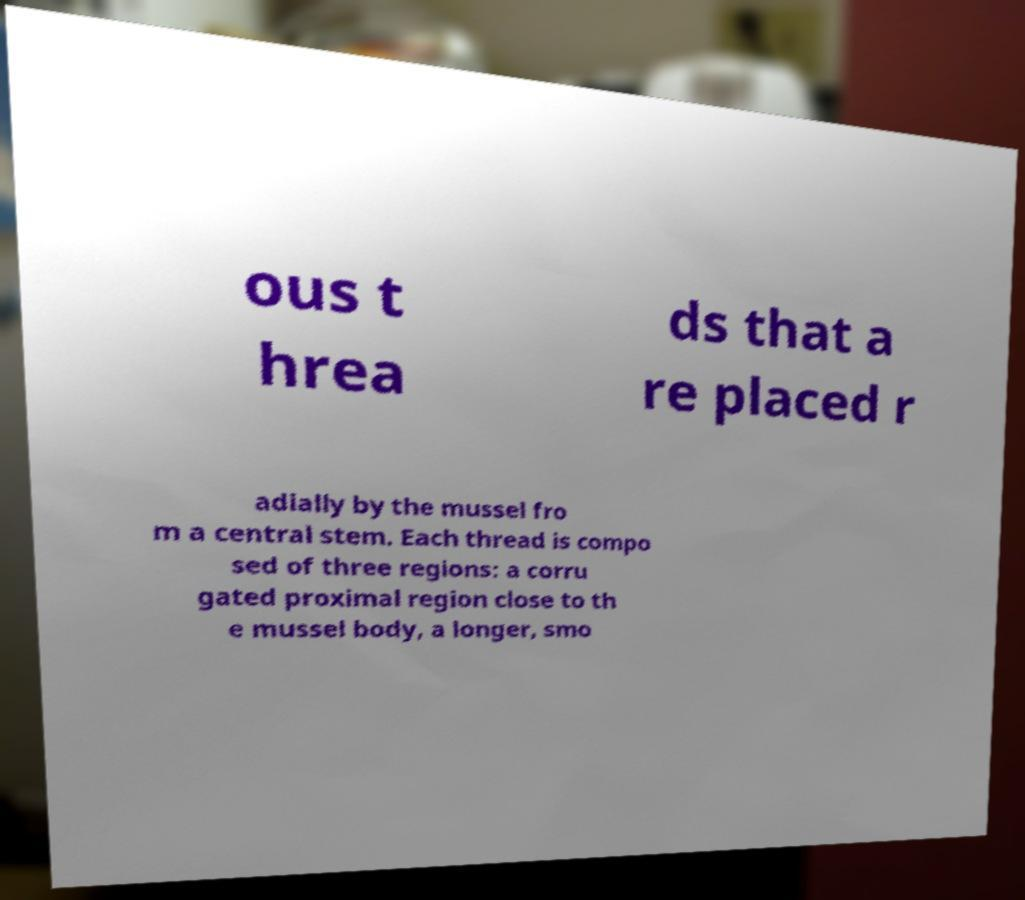Could you assist in decoding the text presented in this image and type it out clearly? ous t hrea ds that a re placed r adially by the mussel fro m a central stem. Each thread is compo sed of three regions: a corru gated proximal region close to th e mussel body, a longer, smo 